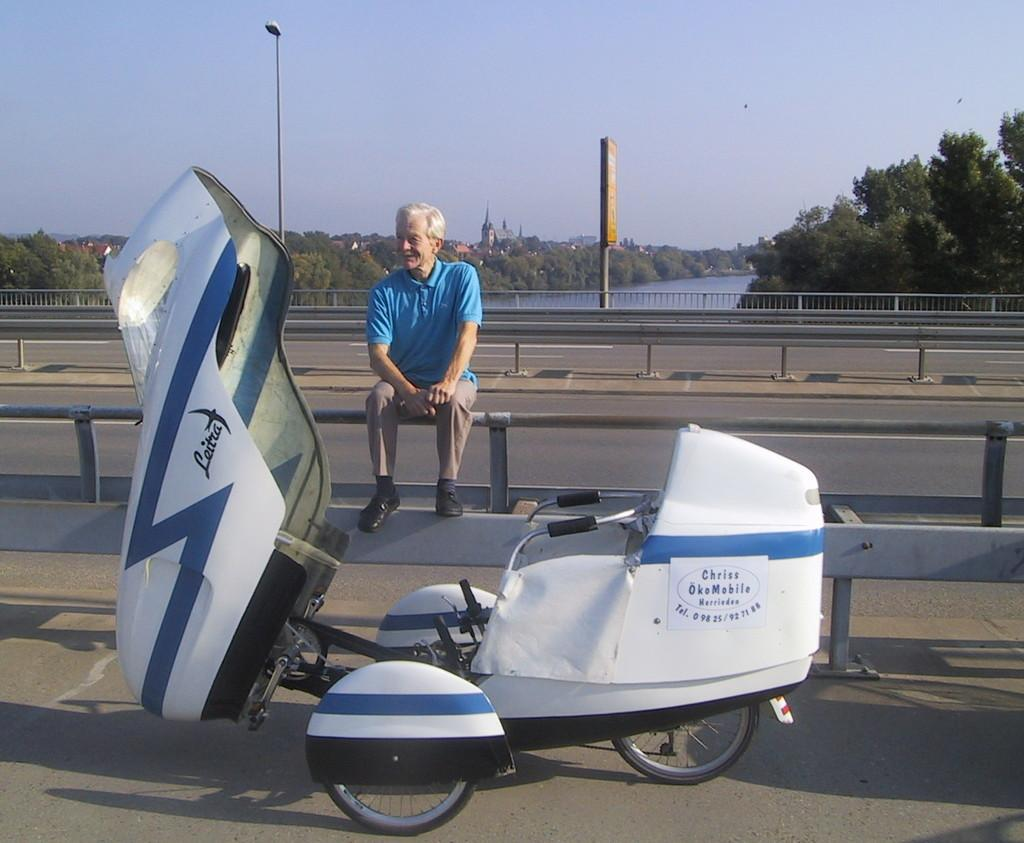<image>
Write a terse but informative summary of the picture. The Scooter has an ad for Chriss OkeMobile on the side 